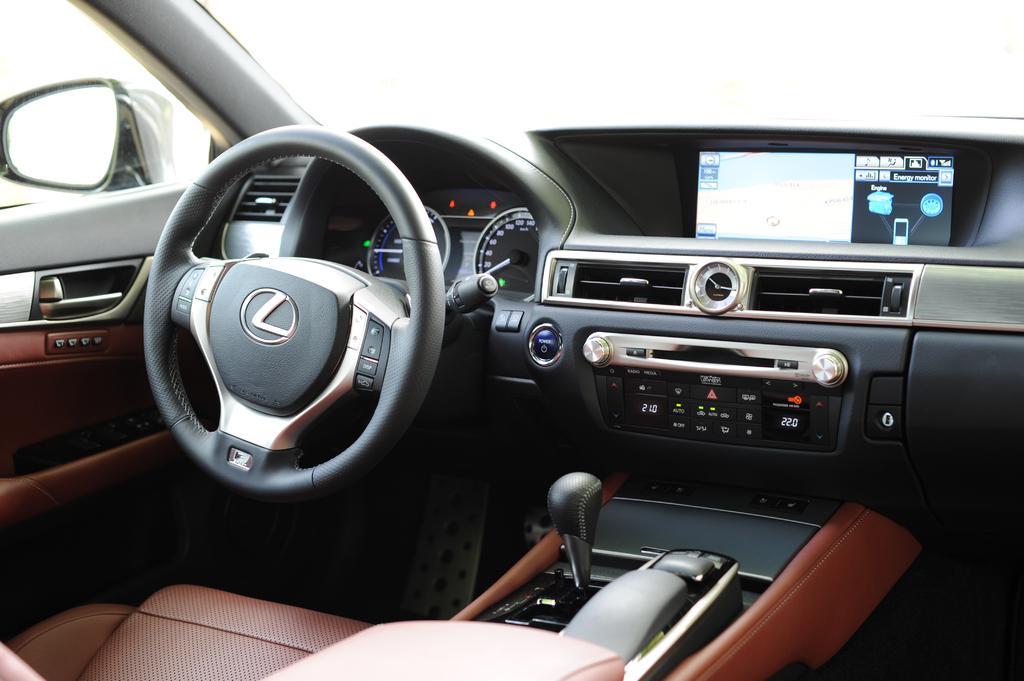Could you give a brief overview of what you see in this image? This is an inside view of a car and here we can see a steering, some buttons, screen, handle and there is a seat and we can see a mirror. 